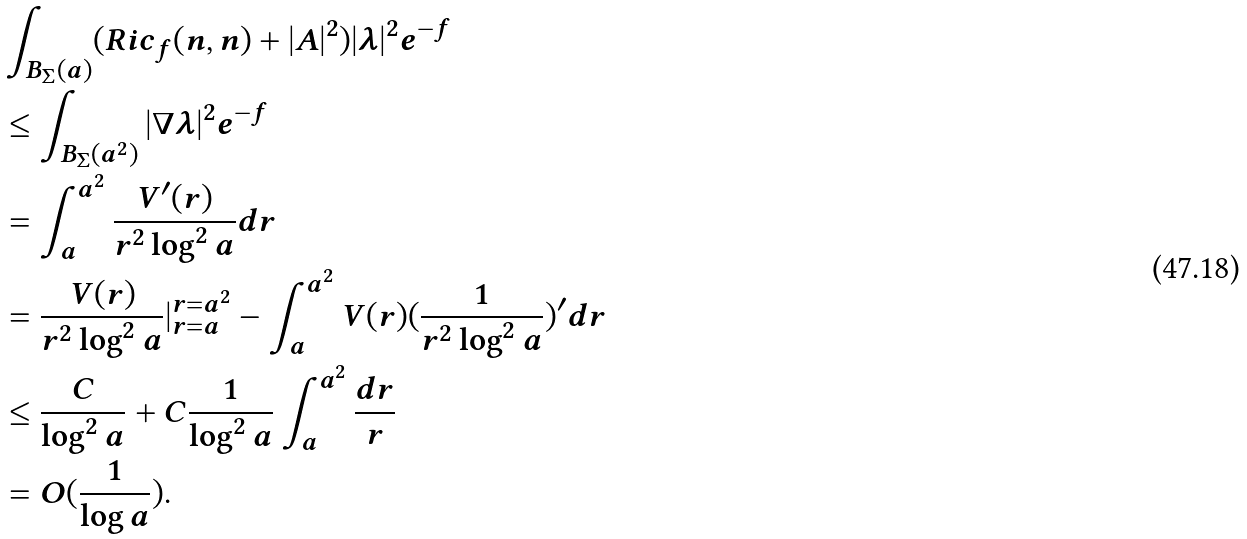<formula> <loc_0><loc_0><loc_500><loc_500>& \int _ { B _ { \Sigma } ( a ) } ( R i c _ { f } ( n , n ) + | A | ^ { 2 } ) | \lambda | ^ { 2 } e ^ { - f } \\ & \leq \int _ { B _ { \Sigma } ( a ^ { 2 } ) } | \nabla \lambda | ^ { 2 } e ^ { - f } \\ & = \int _ { a } ^ { a ^ { 2 } } \frac { V ^ { \prime } ( r ) } { r ^ { 2 } \log ^ { 2 } a } d r \\ & = \frac { V ( r ) } { r ^ { 2 } \log ^ { 2 } a } | _ { r = a } ^ { r = a ^ { 2 } } - \int _ { a } ^ { a ^ { 2 } } V ( r ) ( \frac { 1 } { r ^ { 2 } \log ^ { 2 } a } ) ^ { \prime } d r \\ & \leq \frac { C } { \log ^ { 2 } a } + C \frac { 1 } { \log ^ { 2 } a } \int _ { a } ^ { a ^ { 2 } } \frac { d r } { r } \\ & = O ( \frac { 1 } { \log a } ) .</formula> 